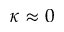Convert formula to latex. <formula><loc_0><loc_0><loc_500><loc_500>\kappa \approx 0</formula> 